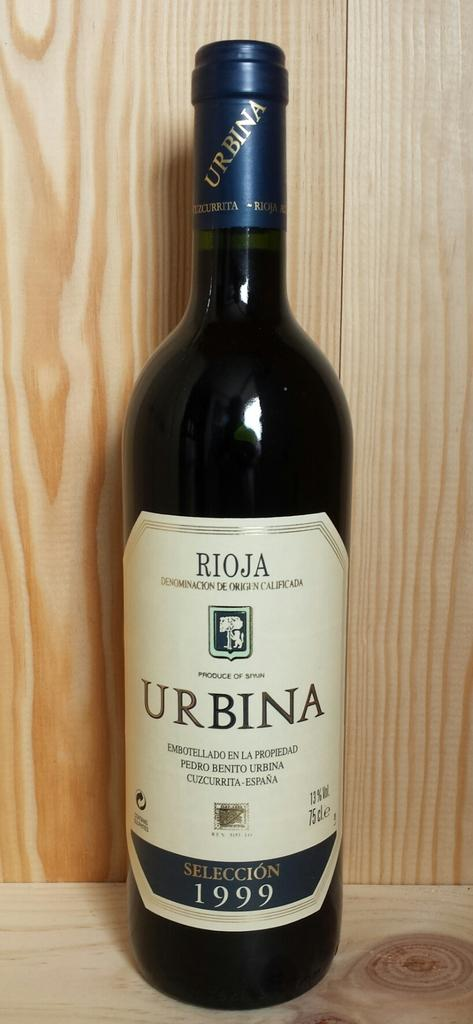What object is present in the image? There is a bottle in the image. What is written on the bottle? The word "URBINA" is written on the bottle. What color is the bottle? The bottle is black in color. What material can be seen behind the bottle? There is wood behind the bottle. What type of trousers is the bottle wearing in the image? The bottle is an inanimate object and does not wear trousers. --- Facts: 1. There is a person in the image. 2. The person is wearing a hat. 3. The person is holding a book. 4. There is a tree in the background. 5. The person is sitting on a bench. Absurd Topics: dance, ocean, parrot Conversation: Who is present in the image? There is a person in the image. What is the person wearing on their head? The person is wearing a hat. What is the person holding in their hands? The person is holding a book. What can be seen in the background of the image? There is a tree in the background. Where is the person sitting in the image? The person is sitting on a bench. Reasoning: Let's think step by step in order to produce the conversation. We start by identifying the main subject in the image, which is the person. Then, we describe specific details about the person, such as their hat, the book they are holding, and where they are sitting. Finally, we mention the background of the image, which includes a tree. Each question is designed to elicit a specific detail about the image that is known from the provided facts. Absurd Question/Answer: Can you see any parrots dancing on the ocean in the image? There is no ocean or parrots present in the image. 